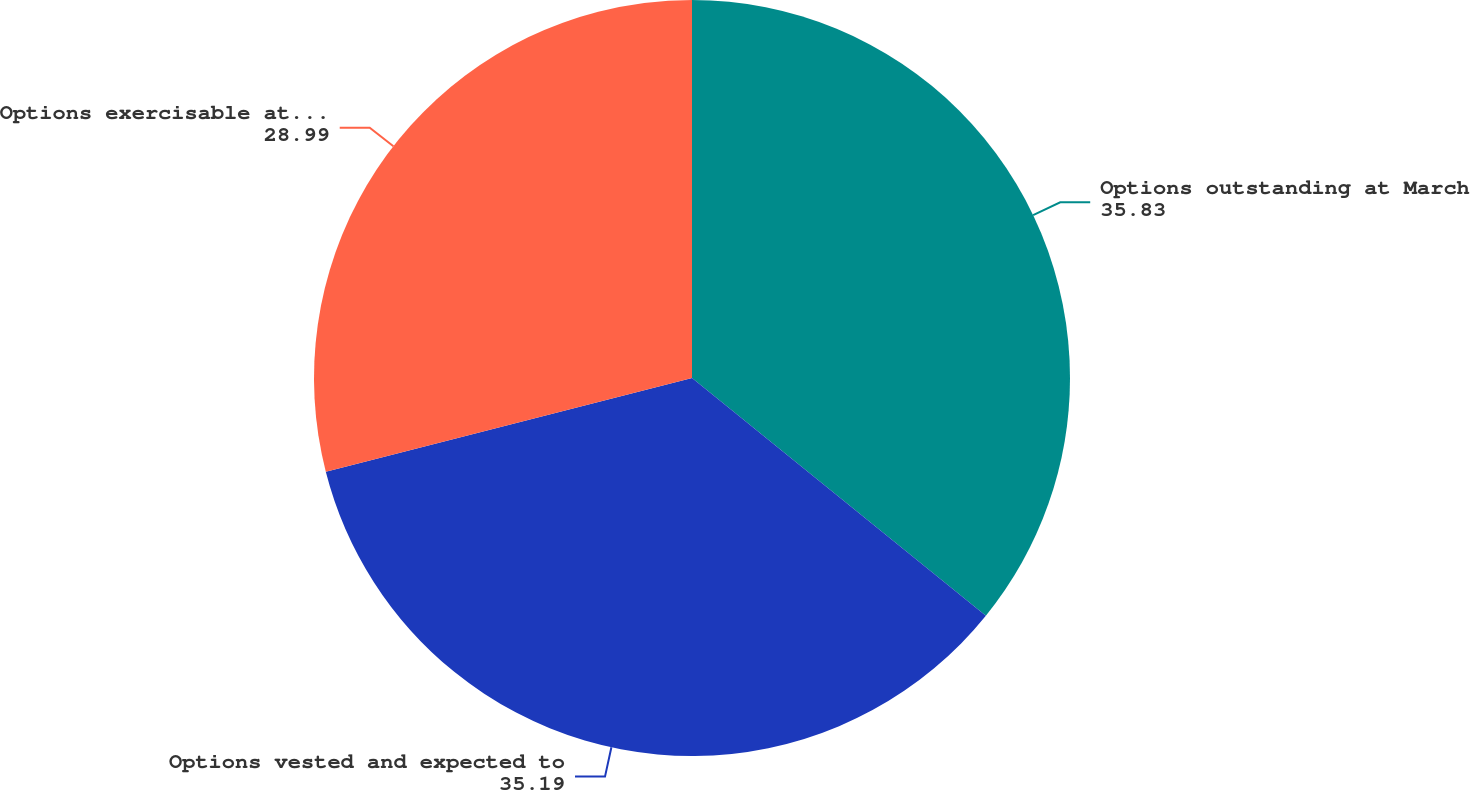Convert chart to OTSL. <chart><loc_0><loc_0><loc_500><loc_500><pie_chart><fcel>Options outstanding at March<fcel>Options vested and expected to<fcel>Options exercisable at March<nl><fcel>35.83%<fcel>35.19%<fcel>28.99%<nl></chart> 